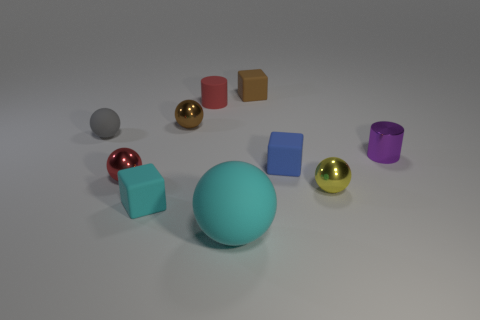What is the relationship between the sizes of the objects? The image depicts objects of varying sizes which allows for a comparison of scale. The central cyan orb is the largest object, and the assorted objects around it, including cubes and cylinders, diminish in size from there. This array could represent a size hierarchy or simply be an artistic composition emphasizing diversity in scale. 